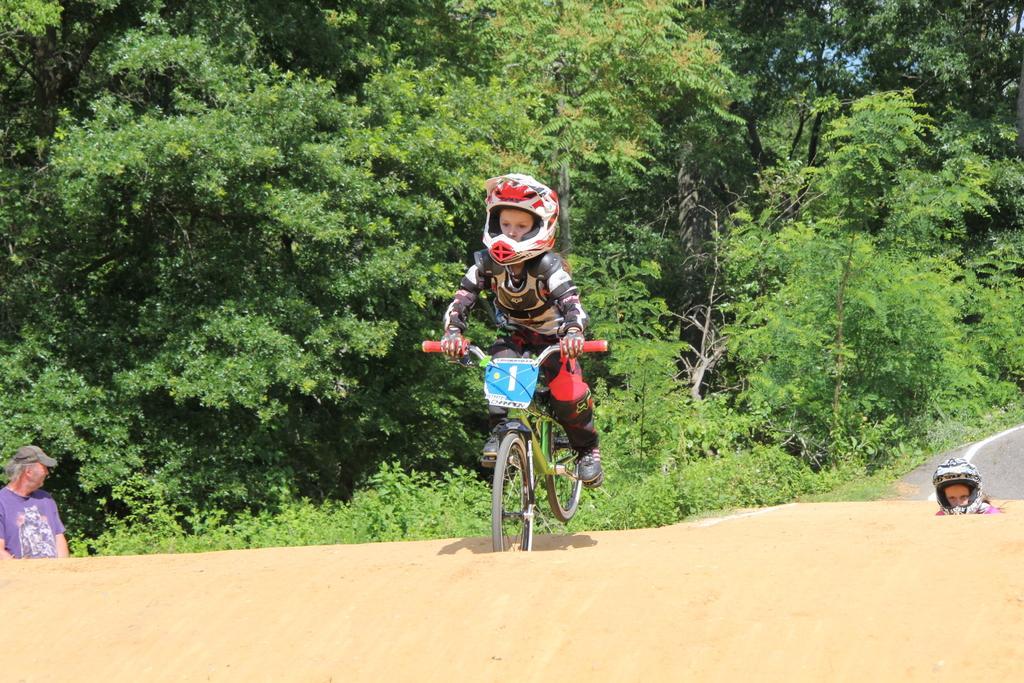Could you give a brief overview of what you see in this image? Here we can see riding a bicycle in the Center wearing the helmet and in the right side we can see another kid, another left side we can see a person standing and behind them there are trees 